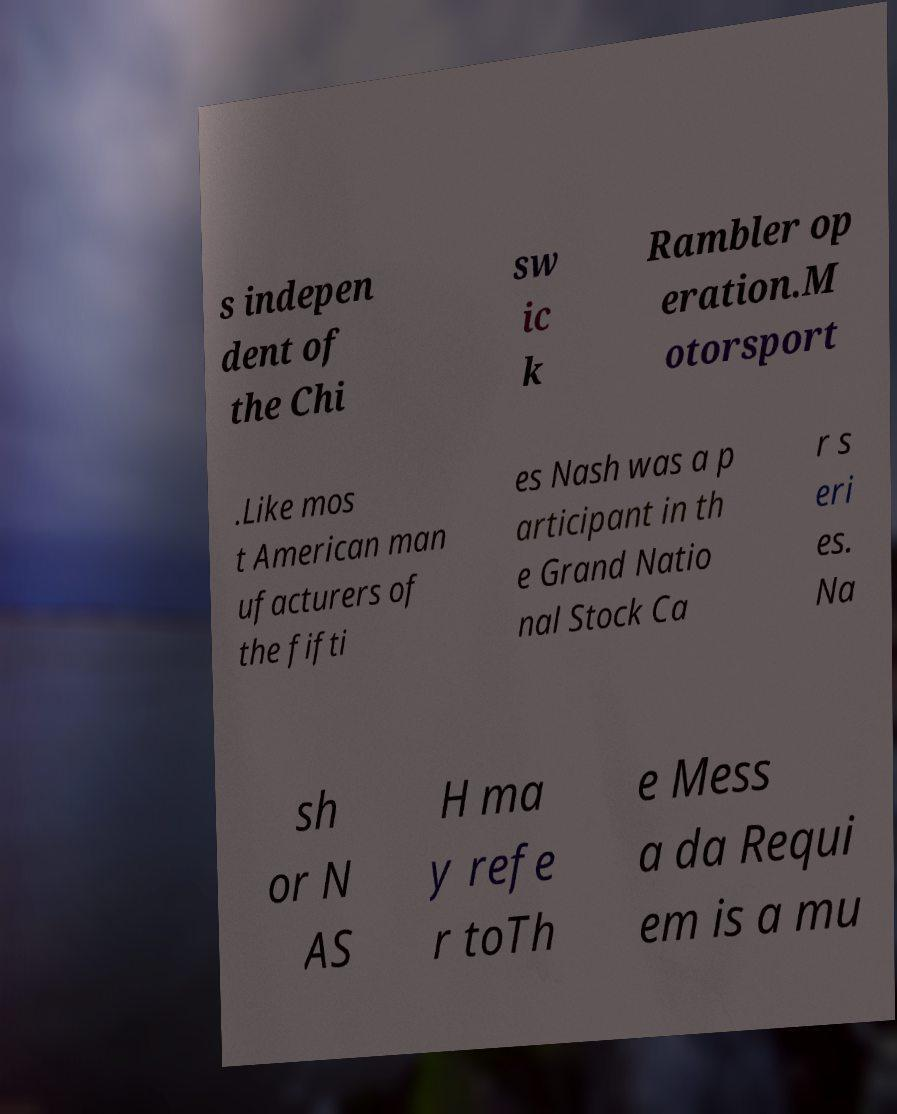For documentation purposes, I need the text within this image transcribed. Could you provide that? s indepen dent of the Chi sw ic k Rambler op eration.M otorsport .Like mos t American man ufacturers of the fifti es Nash was a p articipant in th e Grand Natio nal Stock Ca r s eri es. Na sh or N AS H ma y refe r toTh e Mess a da Requi em is a mu 